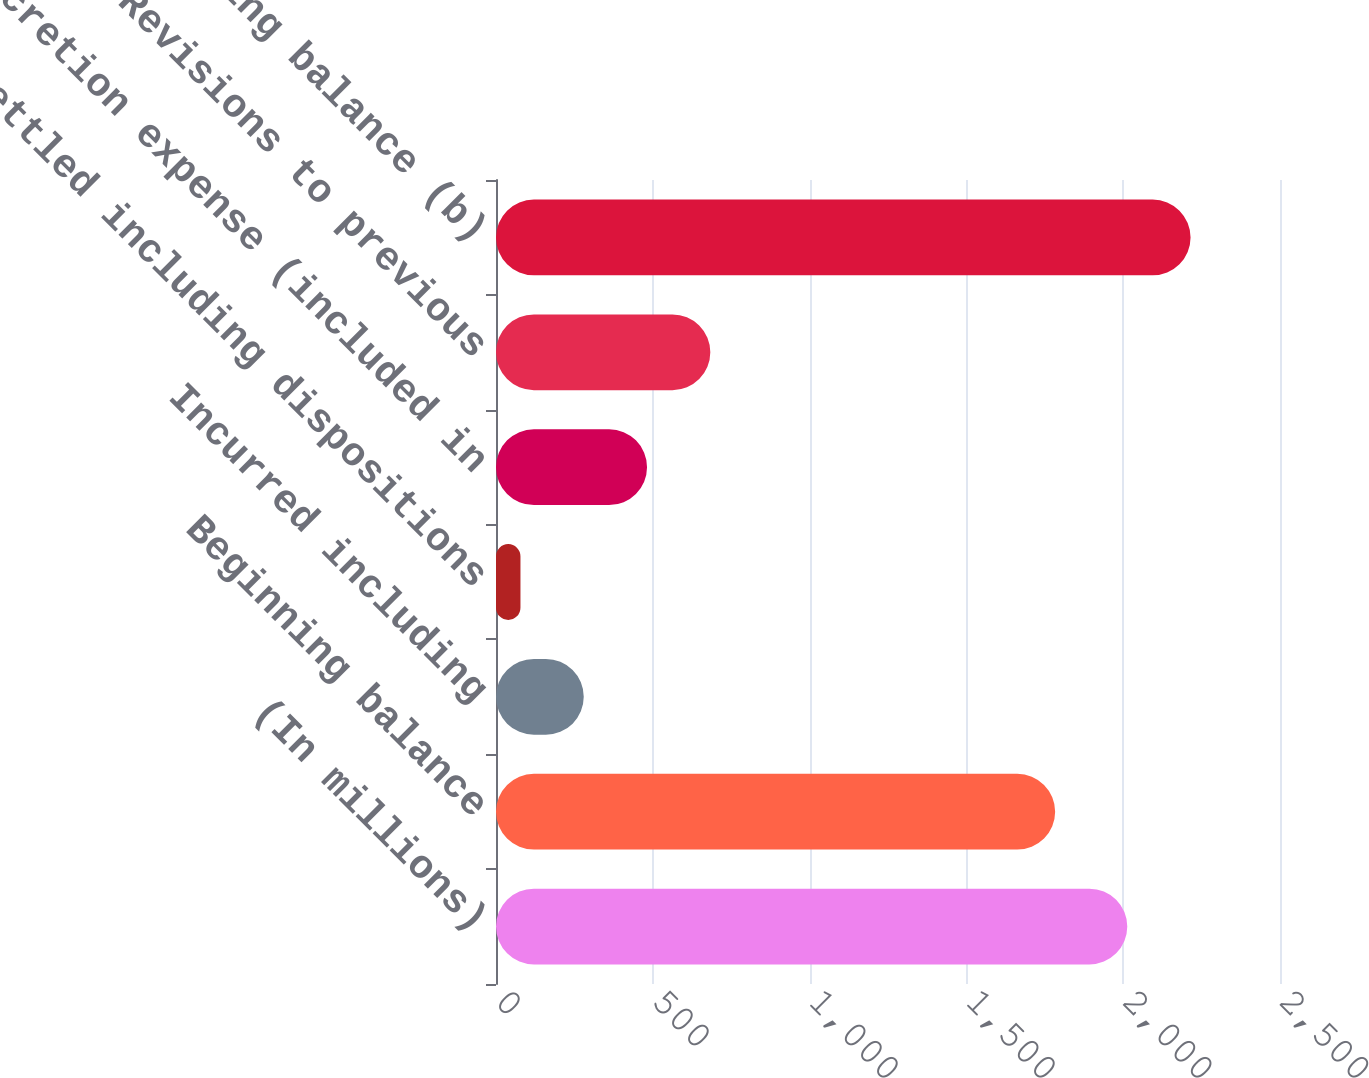Convert chart to OTSL. <chart><loc_0><loc_0><loc_500><loc_500><bar_chart><fcel>(In millions)<fcel>Beginning balance<fcel>Incurred including<fcel>Settled including dispositions<fcel>Accretion expense (included in<fcel>Revisions to previous<fcel>Ending balance (b)<nl><fcel>2013<fcel>1783<fcel>279.8<fcel>78<fcel>481.6<fcel>683.4<fcel>2214.8<nl></chart> 